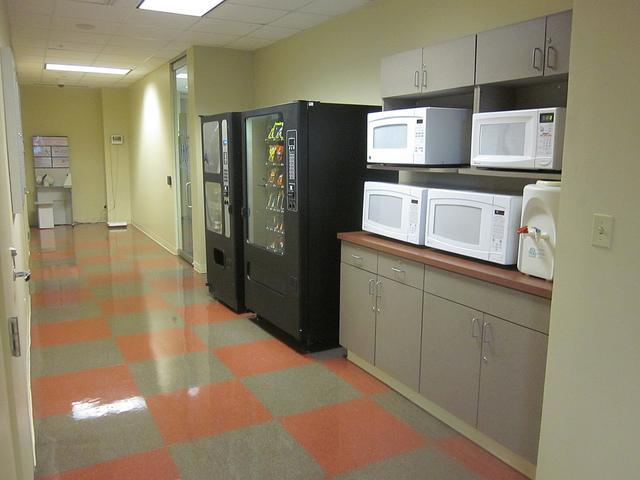How many people can cook food here at once? four 